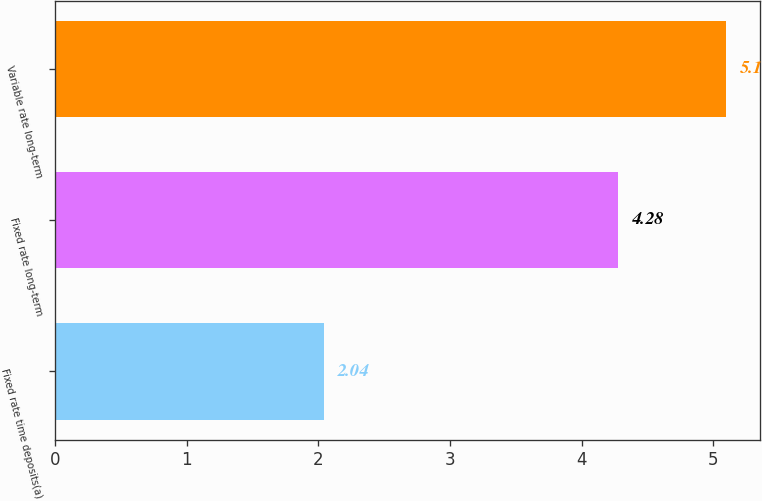Convert chart to OTSL. <chart><loc_0><loc_0><loc_500><loc_500><bar_chart><fcel>Fixed rate time deposits(a)<fcel>Fixed rate long-term<fcel>Variable rate long-term<nl><fcel>2.04<fcel>4.28<fcel>5.1<nl></chart> 